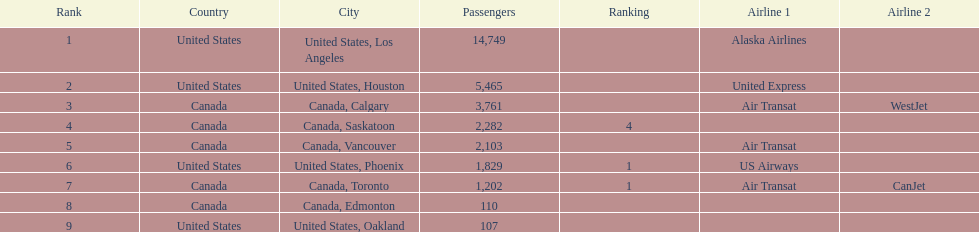What was the number of passengers in phoenix arizona? 1,829. 